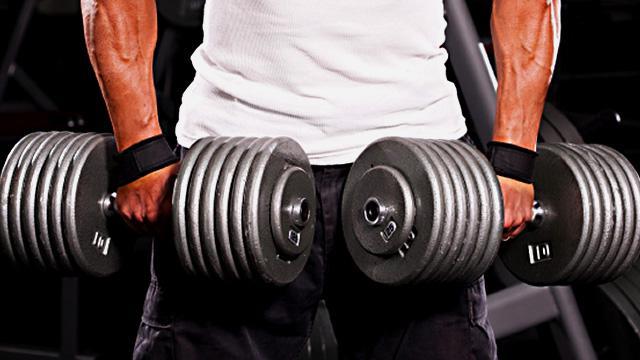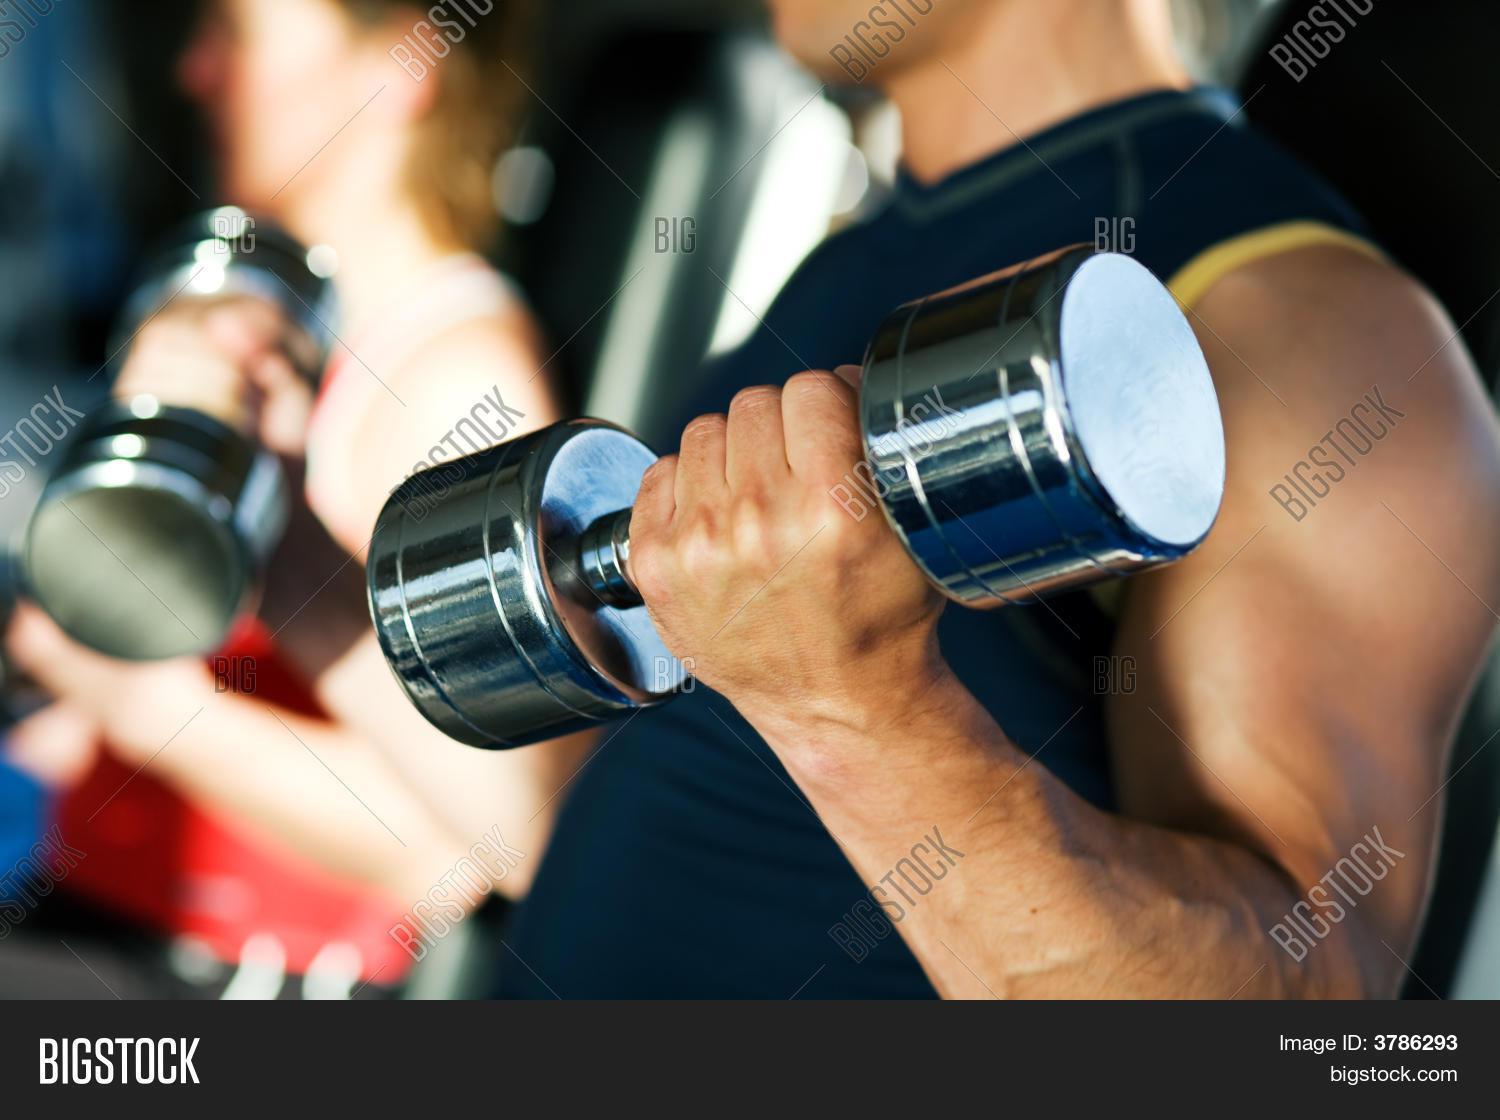The first image is the image on the left, the second image is the image on the right. For the images shown, is this caption "The person in the image on the left is holding one black barbell." true? Answer yes or no. No. 